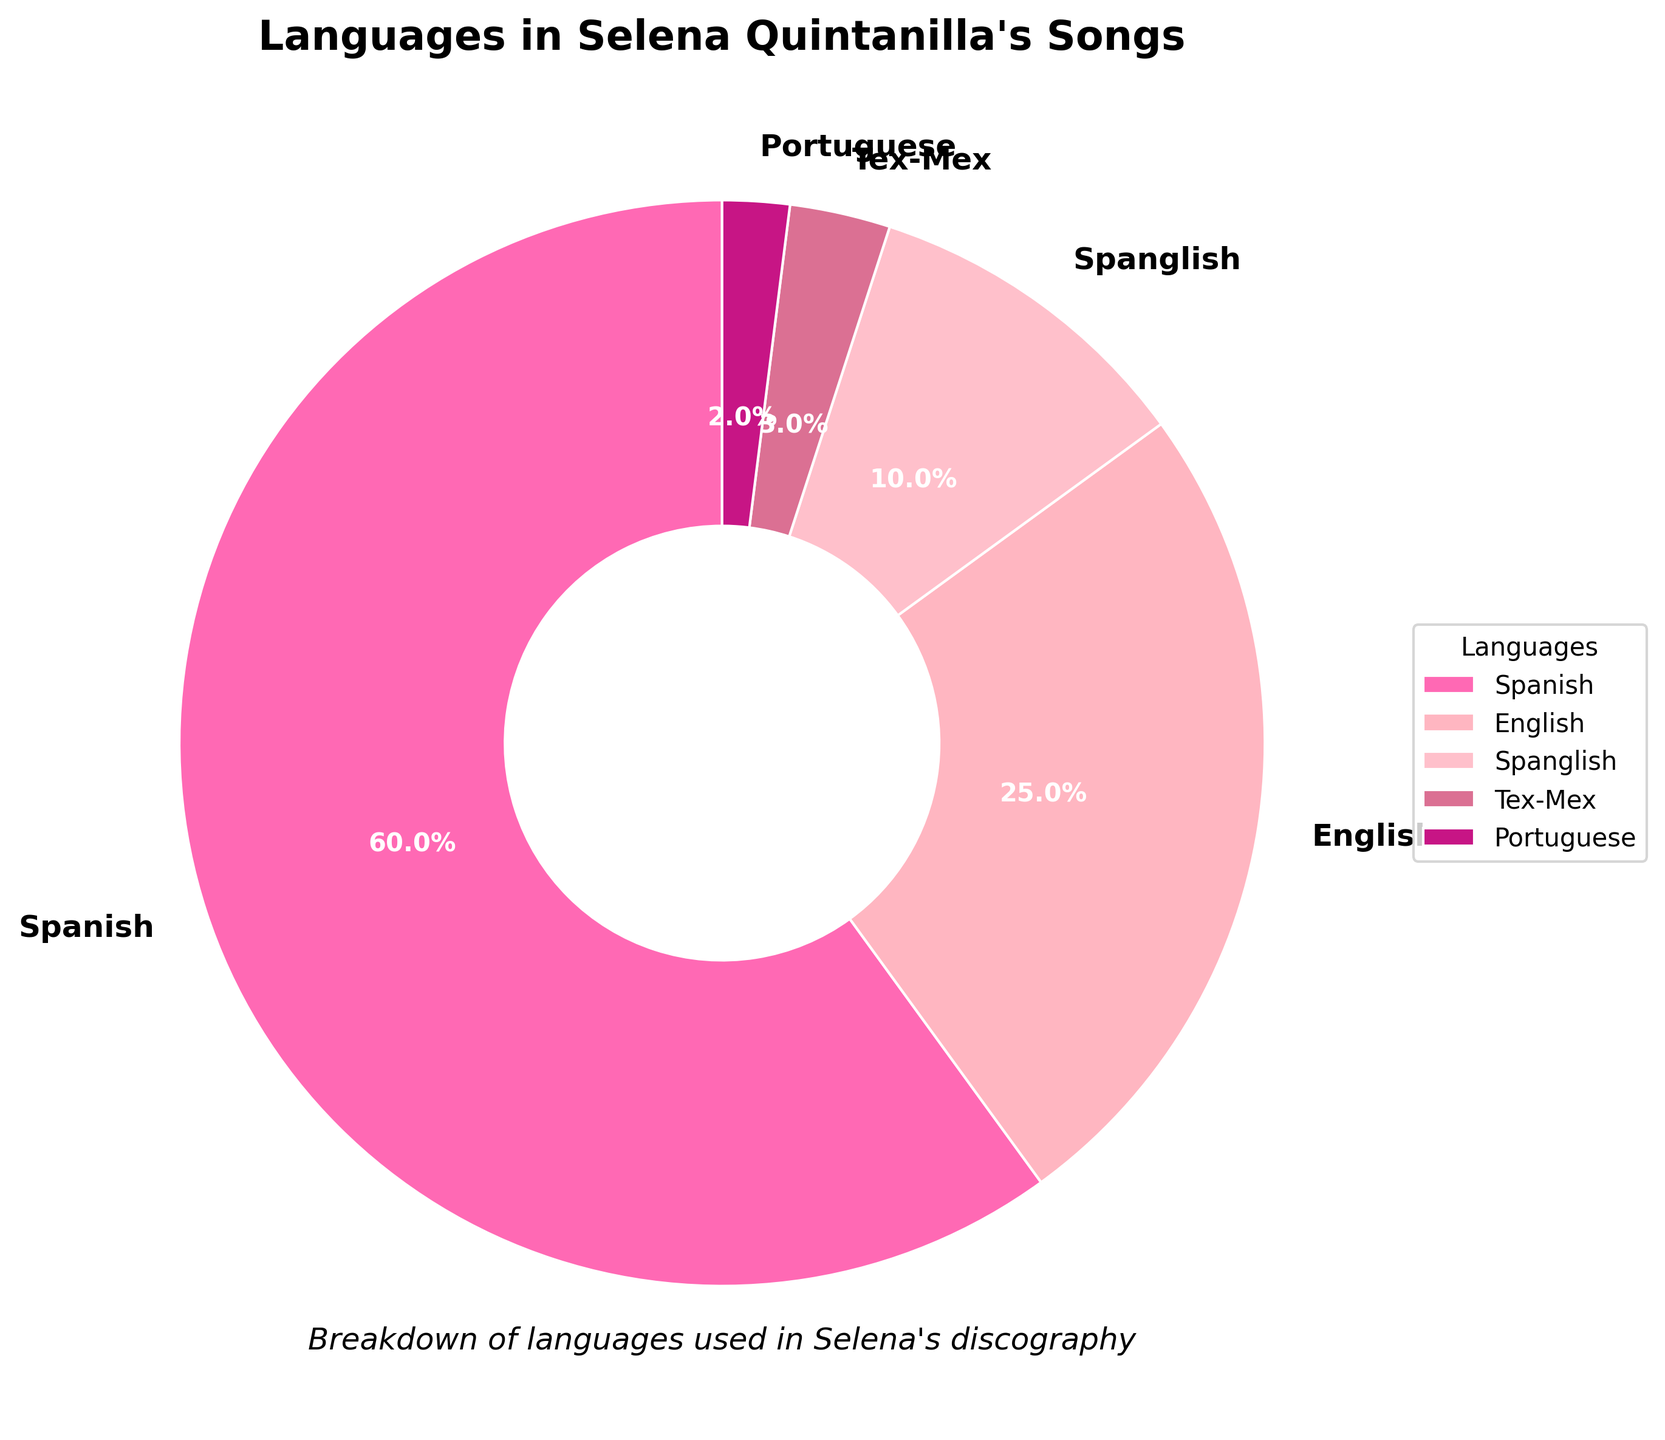What percentage of Selena's songs are in Spanish and English combined? To get the combined percentage of songs in Spanish and English, simply add their individual percentages: 60% (Spanish) + 25% (English) = 85%.
Answer: 85% What is the difference in percentage between songs in Spanish and songs in Spanglish? Subtract the percentage of songs in Spanglish from the percentage of songs in Spanish: 60% (Spanish) - 10% (Spanglish) = 50%.
Answer: 50% How do the percentages of songs in English and Tex-Mex compare? Which is higher and by how much? The percentage of songs in English is 25%, and in Tex-Mex is 3%. Subtract the percentage of Tex-Mex songs from English songs: 25% - 3% = 22%. English is higher by 22%.
Answer: English is higher by 22% Among the languages shown, which one has the least representation in Selena's discography? Look at the percentages and identify the smallest one, which is Portuguese at 2%.
Answer: Portuguese If 150 songs are categorized in this chart, how many songs are sung in Tex-Mex? First, calculate the number of songs in Tex-Mex by using the given percentage: 150 songs * 3% (Tex-Mex) = 4.5. Since the number of songs can't be fractional, round to the nearest whole number, which is 5.
Answer: 5 songs What is the visual color used for the section representing Spanglish songs in the pie chart? Identify the color associated with Spanglish songs in the legend or directly on the pie chart. The visual color for Spanglish songs is pink.
Answer: Pink Which two language segments have a combined representation of 5% of Selena's songs? Combine the two smallest percentages: 3% (Tex-Mex) + 2% (Portuguese) = 5%.
Answer: Tex-Mex and Portuguese How does the size of the Spanish segment visually compare to the English segment in the pie chart? The Spanish segment appears significantly larger than the English segment because it represents 60% compared to 25%.
Answer: Spanish is significantly larger What is the average percentage of Selena's songs that are either in English or Spanglish? Add the percentages for English and Spanglish, then divide by 2: (25% + 10%) / 2 = 17.5%.
Answer: 17.5% What overall percentage of songs are sung either in Tex-Mex or Portuguese? Add the percentages for Tex-Mex and Portuguese: 3% (Tex-Mex) + 2% (Portuguese) = 5%.
Answer: 5% 